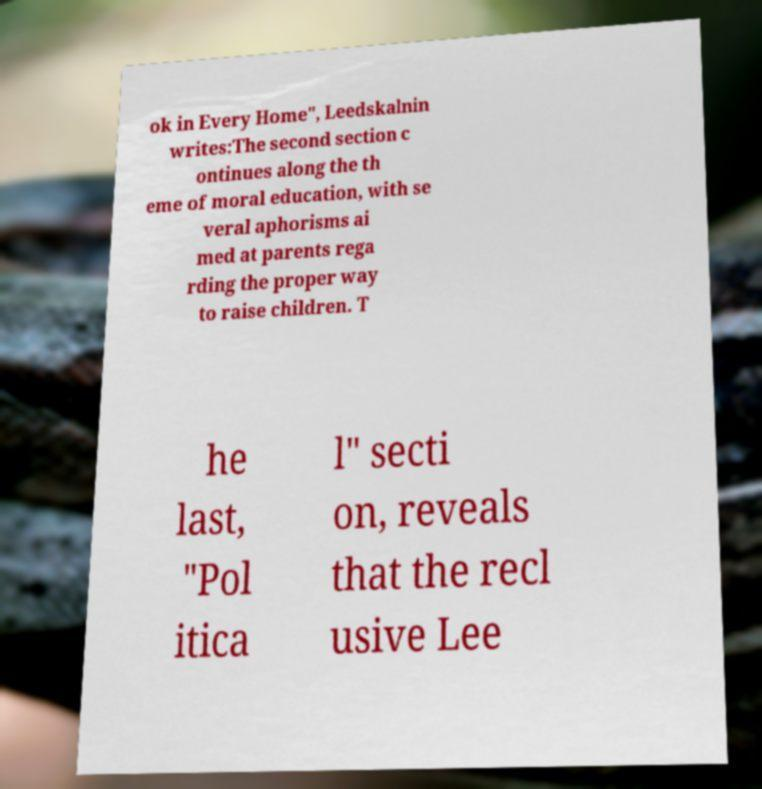For documentation purposes, I need the text within this image transcribed. Could you provide that? ok in Every Home", Leedskalnin writes:The second section c ontinues along the th eme of moral education, with se veral aphorisms ai med at parents rega rding the proper way to raise children. T he last, "Pol itica l" secti on, reveals that the recl usive Lee 